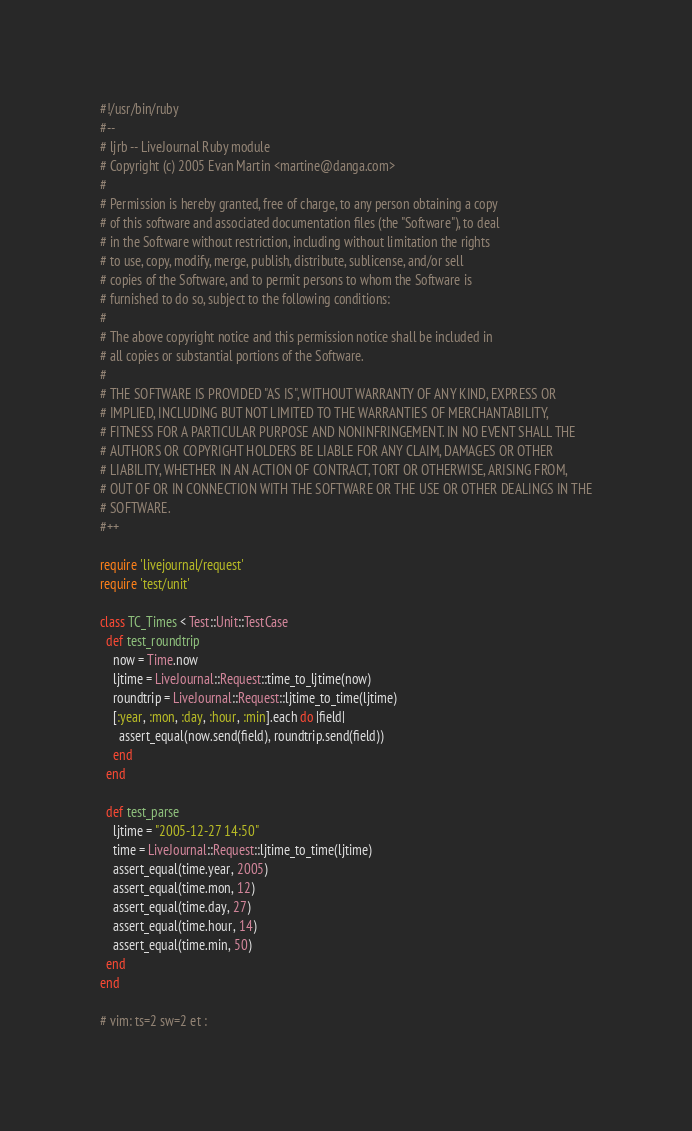Convert code to text. <code><loc_0><loc_0><loc_500><loc_500><_Ruby_>#!/usr/bin/ruby
#--
# ljrb -- LiveJournal Ruby module
# Copyright (c) 2005 Evan Martin <martine@danga.com>
#
# Permission is hereby granted, free of charge, to any person obtaining a copy
# of this software and associated documentation files (the "Software"), to deal
# in the Software without restriction, including without limitation the rights
# to use, copy, modify, merge, publish, distribute, sublicense, and/or sell
# copies of the Software, and to permit persons to whom the Software is
# furnished to do so, subject to the following conditions:
#
# The above copyright notice and this permission notice shall be included in
# all copies or substantial portions of the Software.
#
# THE SOFTWARE IS PROVIDED "AS IS", WITHOUT WARRANTY OF ANY KIND, EXPRESS OR
# IMPLIED, INCLUDING BUT NOT LIMITED TO THE WARRANTIES OF MERCHANTABILITY,
# FITNESS FOR A PARTICULAR PURPOSE AND NONINFRINGEMENT. IN NO EVENT SHALL THE
# AUTHORS OR COPYRIGHT HOLDERS BE LIABLE FOR ANY CLAIM, DAMAGES OR OTHER
# LIABILITY, WHETHER IN AN ACTION OF CONTRACT, TORT OR OTHERWISE, ARISING FROM,
# OUT OF OR IN CONNECTION WITH THE SOFTWARE OR THE USE OR OTHER DEALINGS IN THE
# SOFTWARE.
#++

require 'livejournal/request'
require 'test/unit'

class TC_Times < Test::Unit::TestCase
  def test_roundtrip
    now = Time.now
    ljtime = LiveJournal::Request::time_to_ljtime(now)
    roundtrip = LiveJournal::Request::ljtime_to_time(ljtime)
    [:year, :mon, :day, :hour, :min].each do |field|
      assert_equal(now.send(field), roundtrip.send(field))
    end
  end

  def test_parse
    ljtime = "2005-12-27 14:50"
    time = LiveJournal::Request::ljtime_to_time(ljtime)
    assert_equal(time.year, 2005)
    assert_equal(time.mon, 12)
    assert_equal(time.day, 27)
    assert_equal(time.hour, 14)
    assert_equal(time.min, 50)
  end
end

# vim: ts=2 sw=2 et :
</code> 